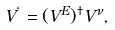Convert formula to latex. <formula><loc_0><loc_0><loc_500><loc_500>V ^ { \ell } = ( V ^ { E } ) ^ { \dagger } V ^ { \nu } ,</formula> 